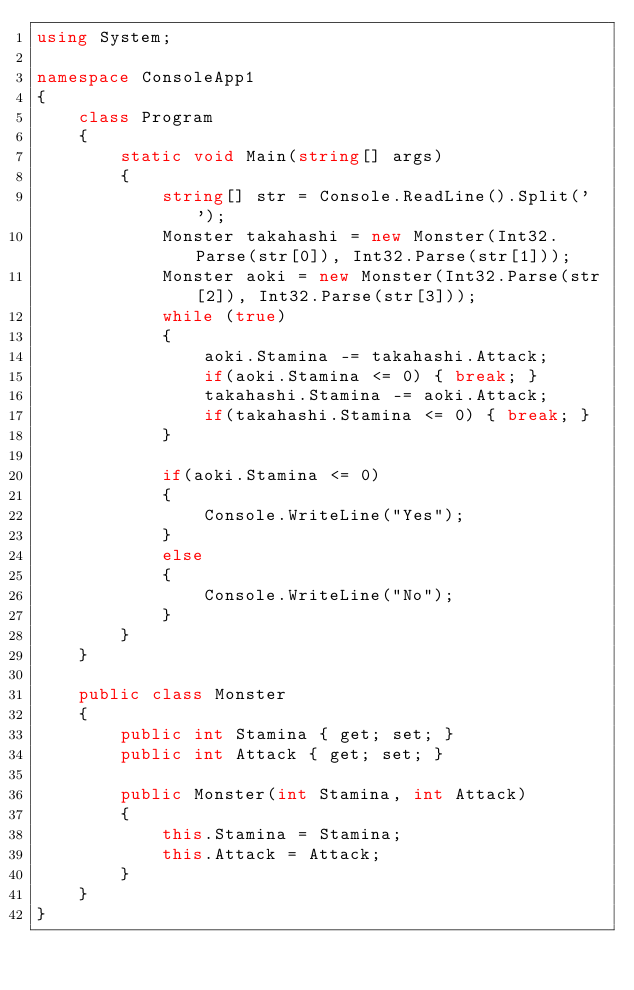Convert code to text. <code><loc_0><loc_0><loc_500><loc_500><_C#_>using System;

namespace ConsoleApp1
{
    class Program
    {
        static void Main(string[] args)
        {
            string[] str = Console.ReadLine().Split(' ');
            Monster takahashi = new Monster(Int32.Parse(str[0]), Int32.Parse(str[1]));
            Monster aoki = new Monster(Int32.Parse(str[2]), Int32.Parse(str[3]));
            while (true)
            {
                aoki.Stamina -= takahashi.Attack;
                if(aoki.Stamina <= 0) { break; }
                takahashi.Stamina -= aoki.Attack;
                if(takahashi.Stamina <= 0) { break; }
            }

            if(aoki.Stamina <= 0)
            {
                Console.WriteLine("Yes");
            }
            else
            {
                Console.WriteLine("No");
            }
        }
    }

    public class Monster
    {
        public int Stamina { get; set; }
        public int Attack { get; set; }

        public Monster(int Stamina, int Attack)
        {
            this.Stamina = Stamina;
            this.Attack = Attack;
        }
    }
}
</code> 